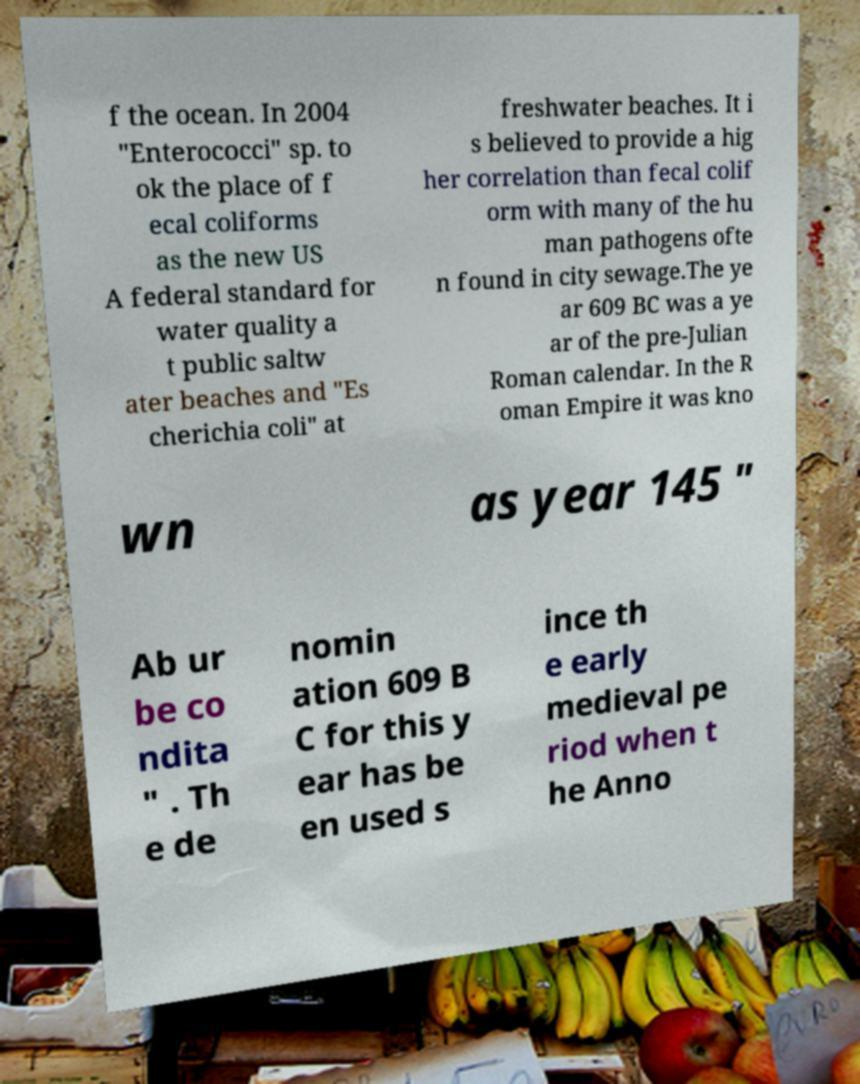For documentation purposes, I need the text within this image transcribed. Could you provide that? f the ocean. In 2004 "Enterococci" sp. to ok the place of f ecal coliforms as the new US A federal standard for water quality a t public saltw ater beaches and "Es cherichia coli" at freshwater beaches. It i s believed to provide a hig her correlation than fecal colif orm with many of the hu man pathogens ofte n found in city sewage.The ye ar 609 BC was a ye ar of the pre-Julian Roman calendar. In the R oman Empire it was kno wn as year 145 " Ab ur be co ndita " . Th e de nomin ation 609 B C for this y ear has be en used s ince th e early medieval pe riod when t he Anno 